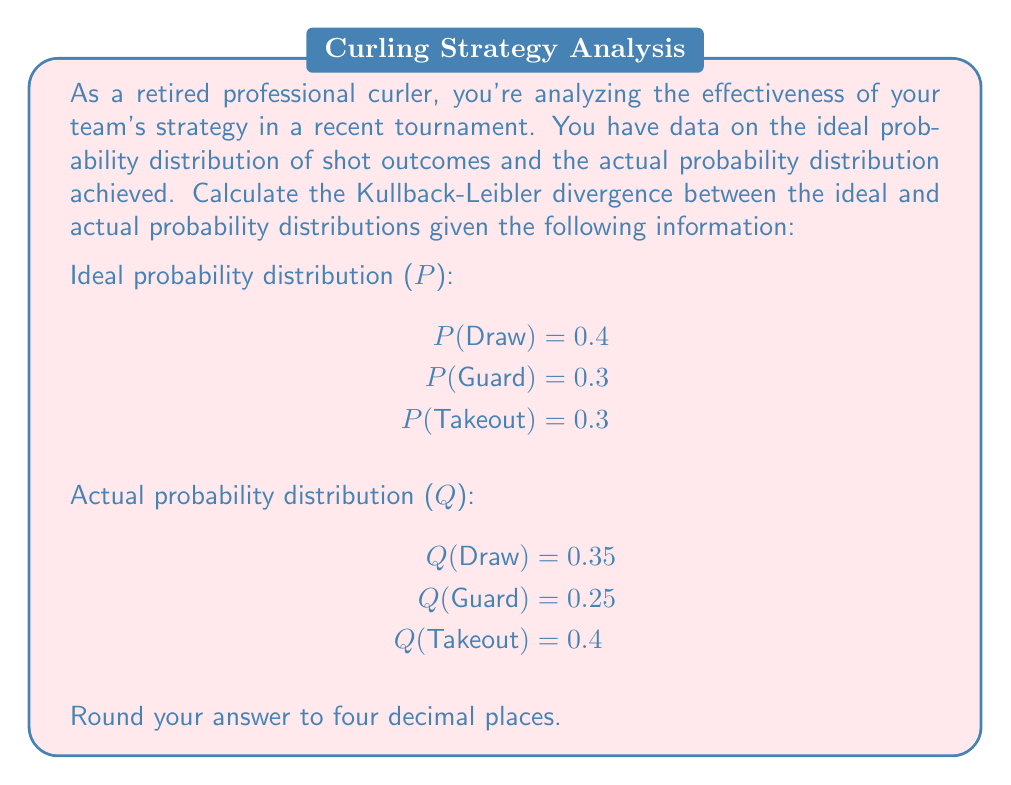Can you answer this question? To solve this problem, we need to use the Kullback-Leibler divergence formula:

$$D_{KL}(P||Q) = \sum_{i} P(i) \log\left(\frac{P(i)}{Q(i)}\right)$$

Where P is the ideal probability distribution and Q is the actual probability distribution.

Let's calculate each term of the sum:

1. For Draw:
   $$P(\text{Draw}) \log\left(\frac{P(\text{Draw})}{Q(\text{Draw})}\right) = 0.4 \log\left(\frac{0.4}{0.35}\right) = 0.4 \times 0.1335 = 0.0534$$

2. For Guard:
   $$P(\text{Guard}) \log\left(\frac{P(\text{Guard})}{Q(\text{Guard})}\right) = 0.3 \log\left(\frac{0.3}{0.25}\right) = 0.3 \times 0.1823 = 0.0547$$

3. For Takeout:
   $$P(\text{Takeout}) \log\left(\frac{P(\text{Takeout})}{Q(\text{Takeout})}\right) = 0.3 \log\left(\frac{0.3}{0.4}\right) = 0.3 \times (-0.2877) = -0.0863$$

Now, we sum these values:

$$D_{KL}(P||Q) = 0.0534 + 0.0547 + (-0.0863) = 0.0218$$

Rounding to four decimal places, we get 0.0218.
Answer: 0.0218 